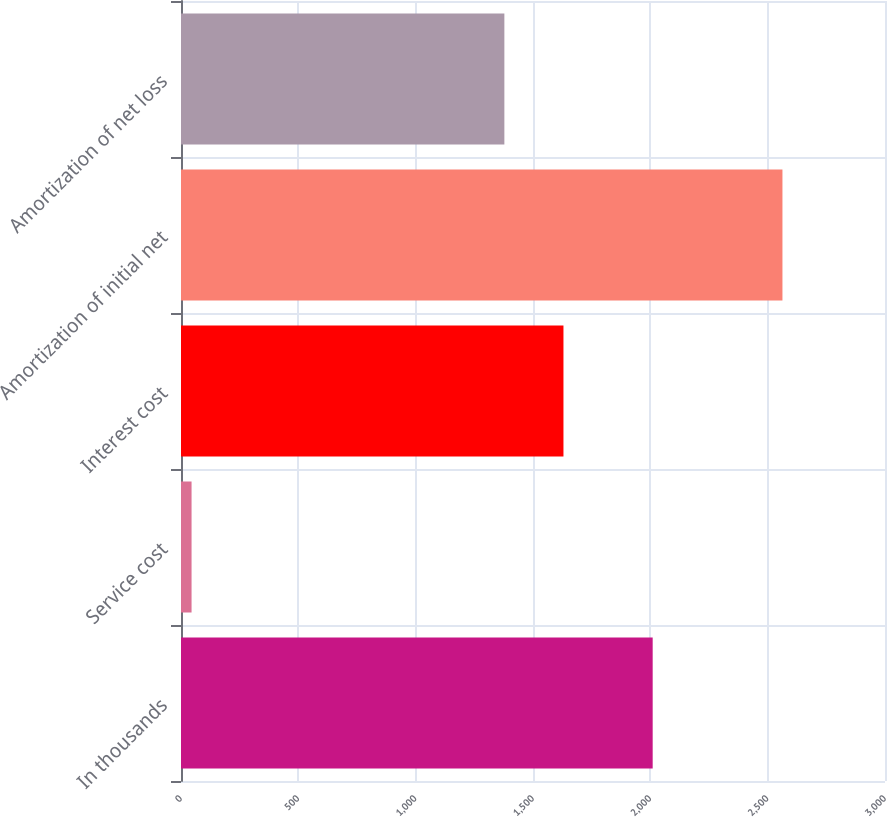<chart> <loc_0><loc_0><loc_500><loc_500><bar_chart><fcel>In thousands<fcel>Service cost<fcel>Interest cost<fcel>Amortization of initial net<fcel>Amortization of net loss<nl><fcel>2010<fcel>45<fcel>1629.8<fcel>2563<fcel>1378<nl></chart> 